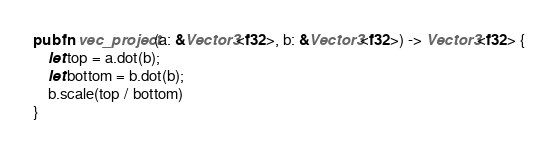<code> <loc_0><loc_0><loc_500><loc_500><_Rust_>pub fn vec_project(a: &Vector3<f32>, b: &Vector3<f32>) -> Vector3<f32> {
    let top = a.dot(b);
    let bottom = b.dot(b);
    b.scale(top / bottom)
}
</code> 